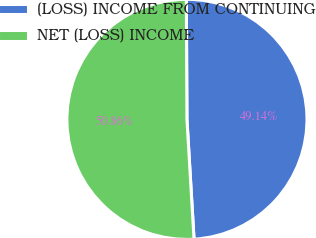Convert chart. <chart><loc_0><loc_0><loc_500><loc_500><pie_chart><fcel>(LOSS) INCOME FROM CONTINUING<fcel>NET (LOSS) INCOME<nl><fcel>49.14%<fcel>50.86%<nl></chart> 